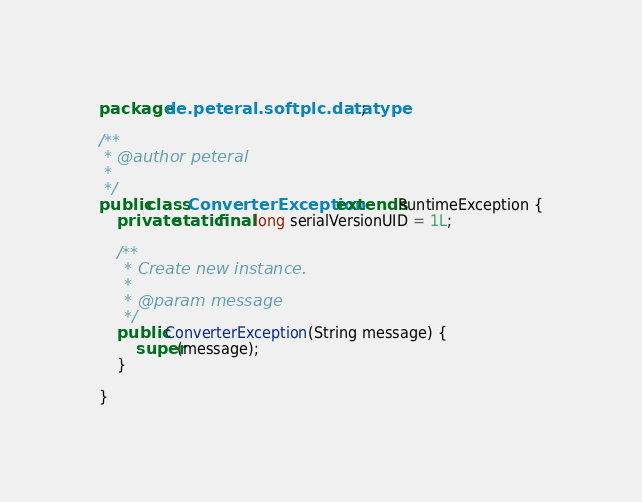Convert code to text. <code><loc_0><loc_0><loc_500><loc_500><_Java_>package de.peteral.softplc.datatype;

/**
 * @author peteral
 *
 */
public class ConverterException extends RuntimeException {
	private static final long serialVersionUID = 1L;

	/**
	 * Create new instance.
	 *
	 * @param message
	 */
	public ConverterException(String message) {
		super(message);
	}

}
</code> 